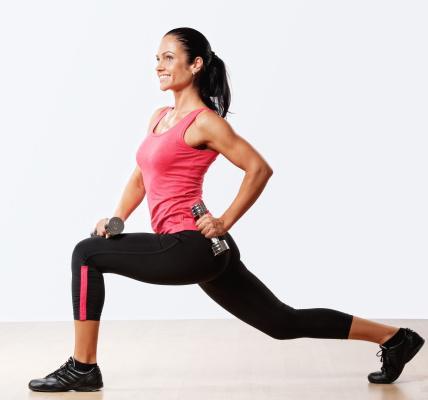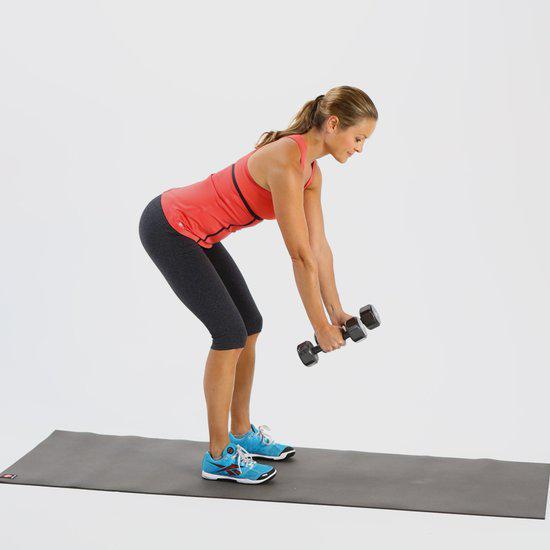The first image is the image on the left, the second image is the image on the right. Given the left and right images, does the statement "The left and right image contains the same number of women using weights." hold true? Answer yes or no. Yes. 